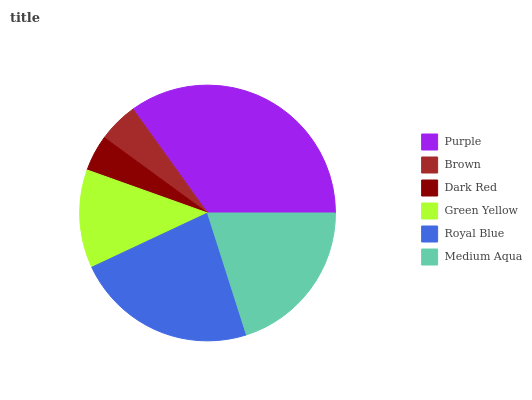Is Dark Red the minimum?
Answer yes or no. Yes. Is Purple the maximum?
Answer yes or no. Yes. Is Brown the minimum?
Answer yes or no. No. Is Brown the maximum?
Answer yes or no. No. Is Purple greater than Brown?
Answer yes or no. Yes. Is Brown less than Purple?
Answer yes or no. Yes. Is Brown greater than Purple?
Answer yes or no. No. Is Purple less than Brown?
Answer yes or no. No. Is Medium Aqua the high median?
Answer yes or no. Yes. Is Green Yellow the low median?
Answer yes or no. Yes. Is Royal Blue the high median?
Answer yes or no. No. Is Brown the low median?
Answer yes or no. No. 